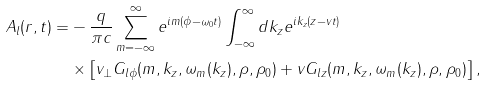Convert formula to latex. <formula><loc_0><loc_0><loc_500><loc_500>A _ { l } ( { r } , t ) = & - \frac { q } { \pi c } \sum _ { m = - \infty } ^ { \infty } e ^ { i m ( \phi - \omega _ { 0 } t ) } \int _ { - \infty } ^ { \infty } d k _ { z } e ^ { i k _ { z } ( z - v _ { \| } t ) } \\ & \times \left [ v _ { \perp } G _ { l \phi } ( m , k _ { z } , \omega _ { m } ( k _ { z } ) , \rho , \rho _ { 0 } ) + v _ { \| } G _ { l z } ( m , k _ { z } , \omega _ { m } ( k _ { z } ) , \rho , \rho _ { 0 } ) \right ] ,</formula> 